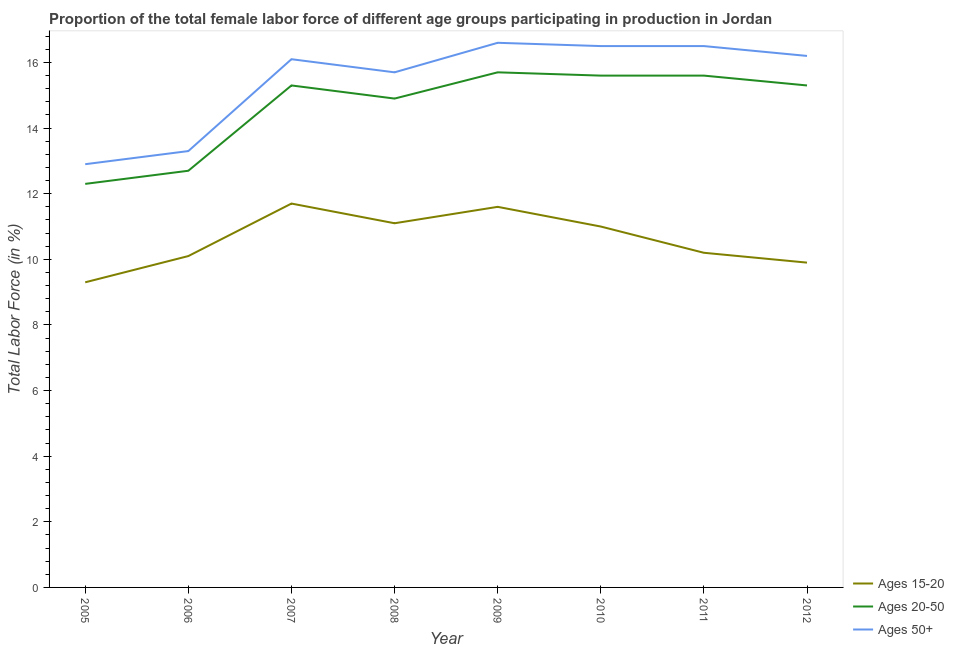What is the percentage of female labor force within the age group 20-50 in 2006?
Provide a succinct answer. 12.7. Across all years, what is the maximum percentage of female labor force above age 50?
Offer a very short reply. 16.6. Across all years, what is the minimum percentage of female labor force above age 50?
Make the answer very short. 12.9. In which year was the percentage of female labor force within the age group 20-50 minimum?
Give a very brief answer. 2005. What is the total percentage of female labor force within the age group 15-20 in the graph?
Provide a short and direct response. 84.9. What is the difference between the percentage of female labor force within the age group 15-20 in 2006 and that in 2009?
Your response must be concise. -1.5. What is the difference between the percentage of female labor force within the age group 15-20 in 2008 and the percentage of female labor force within the age group 20-50 in 2006?
Make the answer very short. -1.6. What is the average percentage of female labor force within the age group 15-20 per year?
Make the answer very short. 10.61. In the year 2012, what is the difference between the percentage of female labor force within the age group 15-20 and percentage of female labor force within the age group 20-50?
Give a very brief answer. -5.4. What is the ratio of the percentage of female labor force within the age group 15-20 in 2005 to that in 2010?
Offer a very short reply. 0.85. Is the percentage of female labor force within the age group 15-20 in 2009 less than that in 2011?
Your answer should be compact. No. What is the difference between the highest and the second highest percentage of female labor force above age 50?
Your answer should be compact. 0.1. What is the difference between the highest and the lowest percentage of female labor force above age 50?
Keep it short and to the point. 3.7. In how many years, is the percentage of female labor force above age 50 greater than the average percentage of female labor force above age 50 taken over all years?
Give a very brief answer. 6. Is the sum of the percentage of female labor force within the age group 20-50 in 2005 and 2008 greater than the maximum percentage of female labor force within the age group 15-20 across all years?
Your answer should be compact. Yes. Is it the case that in every year, the sum of the percentage of female labor force within the age group 15-20 and percentage of female labor force within the age group 20-50 is greater than the percentage of female labor force above age 50?
Give a very brief answer. Yes. Does the percentage of female labor force above age 50 monotonically increase over the years?
Provide a short and direct response. No. Is the percentage of female labor force within the age group 20-50 strictly less than the percentage of female labor force within the age group 15-20 over the years?
Offer a very short reply. No. How many years are there in the graph?
Keep it short and to the point. 8. Does the graph contain any zero values?
Make the answer very short. No. How many legend labels are there?
Provide a succinct answer. 3. What is the title of the graph?
Keep it short and to the point. Proportion of the total female labor force of different age groups participating in production in Jordan. Does "Transport" appear as one of the legend labels in the graph?
Offer a terse response. No. What is the label or title of the X-axis?
Your response must be concise. Year. What is the Total Labor Force (in %) of Ages 15-20 in 2005?
Provide a short and direct response. 9.3. What is the Total Labor Force (in %) in Ages 20-50 in 2005?
Your answer should be very brief. 12.3. What is the Total Labor Force (in %) in Ages 50+ in 2005?
Offer a very short reply. 12.9. What is the Total Labor Force (in %) of Ages 15-20 in 2006?
Give a very brief answer. 10.1. What is the Total Labor Force (in %) of Ages 20-50 in 2006?
Your answer should be very brief. 12.7. What is the Total Labor Force (in %) of Ages 50+ in 2006?
Provide a succinct answer. 13.3. What is the Total Labor Force (in %) in Ages 15-20 in 2007?
Make the answer very short. 11.7. What is the Total Labor Force (in %) of Ages 20-50 in 2007?
Keep it short and to the point. 15.3. What is the Total Labor Force (in %) in Ages 50+ in 2007?
Ensure brevity in your answer.  16.1. What is the Total Labor Force (in %) in Ages 15-20 in 2008?
Provide a succinct answer. 11.1. What is the Total Labor Force (in %) in Ages 20-50 in 2008?
Ensure brevity in your answer.  14.9. What is the Total Labor Force (in %) of Ages 50+ in 2008?
Keep it short and to the point. 15.7. What is the Total Labor Force (in %) of Ages 15-20 in 2009?
Ensure brevity in your answer.  11.6. What is the Total Labor Force (in %) in Ages 20-50 in 2009?
Make the answer very short. 15.7. What is the Total Labor Force (in %) in Ages 50+ in 2009?
Ensure brevity in your answer.  16.6. What is the Total Labor Force (in %) of Ages 15-20 in 2010?
Your response must be concise. 11. What is the Total Labor Force (in %) in Ages 20-50 in 2010?
Your response must be concise. 15.6. What is the Total Labor Force (in %) in Ages 50+ in 2010?
Give a very brief answer. 16.5. What is the Total Labor Force (in %) of Ages 15-20 in 2011?
Offer a very short reply. 10.2. What is the Total Labor Force (in %) in Ages 20-50 in 2011?
Give a very brief answer. 15.6. What is the Total Labor Force (in %) of Ages 50+ in 2011?
Keep it short and to the point. 16.5. What is the Total Labor Force (in %) in Ages 15-20 in 2012?
Your answer should be very brief. 9.9. What is the Total Labor Force (in %) of Ages 20-50 in 2012?
Provide a succinct answer. 15.3. What is the Total Labor Force (in %) in Ages 50+ in 2012?
Make the answer very short. 16.2. Across all years, what is the maximum Total Labor Force (in %) of Ages 15-20?
Your answer should be very brief. 11.7. Across all years, what is the maximum Total Labor Force (in %) of Ages 20-50?
Make the answer very short. 15.7. Across all years, what is the maximum Total Labor Force (in %) in Ages 50+?
Keep it short and to the point. 16.6. Across all years, what is the minimum Total Labor Force (in %) of Ages 15-20?
Provide a succinct answer. 9.3. Across all years, what is the minimum Total Labor Force (in %) of Ages 20-50?
Give a very brief answer. 12.3. Across all years, what is the minimum Total Labor Force (in %) in Ages 50+?
Make the answer very short. 12.9. What is the total Total Labor Force (in %) in Ages 15-20 in the graph?
Give a very brief answer. 84.9. What is the total Total Labor Force (in %) in Ages 20-50 in the graph?
Ensure brevity in your answer.  117.4. What is the total Total Labor Force (in %) of Ages 50+ in the graph?
Ensure brevity in your answer.  123.8. What is the difference between the Total Labor Force (in %) in Ages 20-50 in 2005 and that in 2006?
Your response must be concise. -0.4. What is the difference between the Total Labor Force (in %) of Ages 50+ in 2005 and that in 2006?
Your answer should be compact. -0.4. What is the difference between the Total Labor Force (in %) in Ages 20-50 in 2005 and that in 2007?
Your response must be concise. -3. What is the difference between the Total Labor Force (in %) of Ages 15-20 in 2005 and that in 2008?
Give a very brief answer. -1.8. What is the difference between the Total Labor Force (in %) of Ages 20-50 in 2005 and that in 2008?
Ensure brevity in your answer.  -2.6. What is the difference between the Total Labor Force (in %) in Ages 50+ in 2005 and that in 2009?
Give a very brief answer. -3.7. What is the difference between the Total Labor Force (in %) in Ages 15-20 in 2005 and that in 2010?
Make the answer very short. -1.7. What is the difference between the Total Labor Force (in %) in Ages 15-20 in 2005 and that in 2011?
Give a very brief answer. -0.9. What is the difference between the Total Labor Force (in %) of Ages 20-50 in 2005 and that in 2011?
Make the answer very short. -3.3. What is the difference between the Total Labor Force (in %) in Ages 50+ in 2005 and that in 2011?
Your answer should be compact. -3.6. What is the difference between the Total Labor Force (in %) in Ages 50+ in 2005 and that in 2012?
Your answer should be very brief. -3.3. What is the difference between the Total Labor Force (in %) of Ages 20-50 in 2006 and that in 2007?
Provide a short and direct response. -2.6. What is the difference between the Total Labor Force (in %) of Ages 15-20 in 2006 and that in 2008?
Provide a short and direct response. -1. What is the difference between the Total Labor Force (in %) in Ages 15-20 in 2006 and that in 2009?
Ensure brevity in your answer.  -1.5. What is the difference between the Total Labor Force (in %) in Ages 50+ in 2006 and that in 2009?
Make the answer very short. -3.3. What is the difference between the Total Labor Force (in %) in Ages 15-20 in 2006 and that in 2010?
Offer a very short reply. -0.9. What is the difference between the Total Labor Force (in %) of Ages 15-20 in 2006 and that in 2011?
Ensure brevity in your answer.  -0.1. What is the difference between the Total Labor Force (in %) of Ages 20-50 in 2006 and that in 2011?
Give a very brief answer. -2.9. What is the difference between the Total Labor Force (in %) of Ages 20-50 in 2006 and that in 2012?
Offer a very short reply. -2.6. What is the difference between the Total Labor Force (in %) of Ages 20-50 in 2007 and that in 2008?
Offer a very short reply. 0.4. What is the difference between the Total Labor Force (in %) of Ages 50+ in 2007 and that in 2008?
Make the answer very short. 0.4. What is the difference between the Total Labor Force (in %) of Ages 20-50 in 2007 and that in 2009?
Offer a terse response. -0.4. What is the difference between the Total Labor Force (in %) in Ages 50+ in 2007 and that in 2009?
Provide a short and direct response. -0.5. What is the difference between the Total Labor Force (in %) of Ages 50+ in 2007 and that in 2011?
Give a very brief answer. -0.4. What is the difference between the Total Labor Force (in %) in Ages 15-20 in 2007 and that in 2012?
Make the answer very short. 1.8. What is the difference between the Total Labor Force (in %) of Ages 50+ in 2007 and that in 2012?
Make the answer very short. -0.1. What is the difference between the Total Labor Force (in %) in Ages 50+ in 2008 and that in 2009?
Keep it short and to the point. -0.9. What is the difference between the Total Labor Force (in %) in Ages 15-20 in 2008 and that in 2010?
Keep it short and to the point. 0.1. What is the difference between the Total Labor Force (in %) in Ages 20-50 in 2008 and that in 2010?
Provide a succinct answer. -0.7. What is the difference between the Total Labor Force (in %) of Ages 20-50 in 2008 and that in 2011?
Your answer should be compact. -0.7. What is the difference between the Total Labor Force (in %) in Ages 50+ in 2008 and that in 2011?
Give a very brief answer. -0.8. What is the difference between the Total Labor Force (in %) of Ages 20-50 in 2008 and that in 2012?
Ensure brevity in your answer.  -0.4. What is the difference between the Total Labor Force (in %) of Ages 50+ in 2008 and that in 2012?
Give a very brief answer. -0.5. What is the difference between the Total Labor Force (in %) in Ages 15-20 in 2009 and that in 2010?
Your response must be concise. 0.6. What is the difference between the Total Labor Force (in %) of Ages 50+ in 2009 and that in 2010?
Make the answer very short. 0.1. What is the difference between the Total Labor Force (in %) of Ages 50+ in 2009 and that in 2011?
Provide a succinct answer. 0.1. What is the difference between the Total Labor Force (in %) in Ages 15-20 in 2009 and that in 2012?
Keep it short and to the point. 1.7. What is the difference between the Total Labor Force (in %) in Ages 20-50 in 2009 and that in 2012?
Provide a succinct answer. 0.4. What is the difference between the Total Labor Force (in %) of Ages 15-20 in 2010 and that in 2011?
Your response must be concise. 0.8. What is the difference between the Total Labor Force (in %) in Ages 20-50 in 2010 and that in 2011?
Offer a terse response. 0. What is the difference between the Total Labor Force (in %) in Ages 15-20 in 2011 and that in 2012?
Your answer should be very brief. 0.3. What is the difference between the Total Labor Force (in %) of Ages 20-50 in 2011 and that in 2012?
Offer a terse response. 0.3. What is the difference between the Total Labor Force (in %) of Ages 50+ in 2011 and that in 2012?
Your answer should be very brief. 0.3. What is the difference between the Total Labor Force (in %) in Ages 15-20 in 2005 and the Total Labor Force (in %) in Ages 20-50 in 2006?
Ensure brevity in your answer.  -3.4. What is the difference between the Total Labor Force (in %) of Ages 15-20 in 2005 and the Total Labor Force (in %) of Ages 20-50 in 2007?
Offer a terse response. -6. What is the difference between the Total Labor Force (in %) of Ages 15-20 in 2005 and the Total Labor Force (in %) of Ages 50+ in 2007?
Provide a succinct answer. -6.8. What is the difference between the Total Labor Force (in %) of Ages 20-50 in 2005 and the Total Labor Force (in %) of Ages 50+ in 2007?
Make the answer very short. -3.8. What is the difference between the Total Labor Force (in %) in Ages 15-20 in 2005 and the Total Labor Force (in %) in Ages 50+ in 2008?
Make the answer very short. -6.4. What is the difference between the Total Labor Force (in %) in Ages 15-20 in 2005 and the Total Labor Force (in %) in Ages 20-50 in 2009?
Make the answer very short. -6.4. What is the difference between the Total Labor Force (in %) in Ages 15-20 in 2005 and the Total Labor Force (in %) in Ages 50+ in 2009?
Provide a short and direct response. -7.3. What is the difference between the Total Labor Force (in %) of Ages 20-50 in 2005 and the Total Labor Force (in %) of Ages 50+ in 2009?
Give a very brief answer. -4.3. What is the difference between the Total Labor Force (in %) of Ages 15-20 in 2005 and the Total Labor Force (in %) of Ages 50+ in 2011?
Your answer should be compact. -7.2. What is the difference between the Total Labor Force (in %) of Ages 20-50 in 2005 and the Total Labor Force (in %) of Ages 50+ in 2011?
Provide a succinct answer. -4.2. What is the difference between the Total Labor Force (in %) of Ages 15-20 in 2006 and the Total Labor Force (in %) of Ages 50+ in 2007?
Keep it short and to the point. -6. What is the difference between the Total Labor Force (in %) of Ages 15-20 in 2006 and the Total Labor Force (in %) of Ages 50+ in 2008?
Give a very brief answer. -5.6. What is the difference between the Total Labor Force (in %) of Ages 20-50 in 2006 and the Total Labor Force (in %) of Ages 50+ in 2008?
Keep it short and to the point. -3. What is the difference between the Total Labor Force (in %) in Ages 15-20 in 2006 and the Total Labor Force (in %) in Ages 20-50 in 2009?
Ensure brevity in your answer.  -5.6. What is the difference between the Total Labor Force (in %) of Ages 20-50 in 2006 and the Total Labor Force (in %) of Ages 50+ in 2009?
Give a very brief answer. -3.9. What is the difference between the Total Labor Force (in %) in Ages 15-20 in 2006 and the Total Labor Force (in %) in Ages 20-50 in 2010?
Your answer should be very brief. -5.5. What is the difference between the Total Labor Force (in %) of Ages 15-20 in 2006 and the Total Labor Force (in %) of Ages 50+ in 2010?
Offer a terse response. -6.4. What is the difference between the Total Labor Force (in %) of Ages 15-20 in 2006 and the Total Labor Force (in %) of Ages 20-50 in 2011?
Give a very brief answer. -5.5. What is the difference between the Total Labor Force (in %) of Ages 15-20 in 2006 and the Total Labor Force (in %) of Ages 50+ in 2011?
Make the answer very short. -6.4. What is the difference between the Total Labor Force (in %) of Ages 15-20 in 2006 and the Total Labor Force (in %) of Ages 20-50 in 2012?
Your answer should be compact. -5.2. What is the difference between the Total Labor Force (in %) in Ages 15-20 in 2006 and the Total Labor Force (in %) in Ages 50+ in 2012?
Ensure brevity in your answer.  -6.1. What is the difference between the Total Labor Force (in %) in Ages 15-20 in 2007 and the Total Labor Force (in %) in Ages 20-50 in 2009?
Your answer should be compact. -4. What is the difference between the Total Labor Force (in %) in Ages 20-50 in 2007 and the Total Labor Force (in %) in Ages 50+ in 2010?
Provide a succinct answer. -1.2. What is the difference between the Total Labor Force (in %) of Ages 15-20 in 2007 and the Total Labor Force (in %) of Ages 50+ in 2011?
Offer a terse response. -4.8. What is the difference between the Total Labor Force (in %) in Ages 15-20 in 2007 and the Total Labor Force (in %) in Ages 20-50 in 2012?
Give a very brief answer. -3.6. What is the difference between the Total Labor Force (in %) of Ages 15-20 in 2008 and the Total Labor Force (in %) of Ages 20-50 in 2009?
Offer a very short reply. -4.6. What is the difference between the Total Labor Force (in %) of Ages 20-50 in 2008 and the Total Labor Force (in %) of Ages 50+ in 2009?
Give a very brief answer. -1.7. What is the difference between the Total Labor Force (in %) in Ages 15-20 in 2008 and the Total Labor Force (in %) in Ages 20-50 in 2010?
Your answer should be compact. -4.5. What is the difference between the Total Labor Force (in %) in Ages 15-20 in 2008 and the Total Labor Force (in %) in Ages 50+ in 2011?
Keep it short and to the point. -5.4. What is the difference between the Total Labor Force (in %) of Ages 15-20 in 2008 and the Total Labor Force (in %) of Ages 20-50 in 2012?
Your response must be concise. -4.2. What is the difference between the Total Labor Force (in %) in Ages 20-50 in 2008 and the Total Labor Force (in %) in Ages 50+ in 2012?
Make the answer very short. -1.3. What is the difference between the Total Labor Force (in %) in Ages 15-20 in 2009 and the Total Labor Force (in %) in Ages 20-50 in 2012?
Offer a very short reply. -3.7. What is the difference between the Total Labor Force (in %) of Ages 15-20 in 2009 and the Total Labor Force (in %) of Ages 50+ in 2012?
Offer a terse response. -4.6. What is the difference between the Total Labor Force (in %) of Ages 20-50 in 2009 and the Total Labor Force (in %) of Ages 50+ in 2012?
Offer a terse response. -0.5. What is the difference between the Total Labor Force (in %) of Ages 15-20 in 2010 and the Total Labor Force (in %) of Ages 20-50 in 2011?
Your answer should be very brief. -4.6. What is the difference between the Total Labor Force (in %) in Ages 20-50 in 2010 and the Total Labor Force (in %) in Ages 50+ in 2011?
Provide a succinct answer. -0.9. What is the difference between the Total Labor Force (in %) in Ages 15-20 in 2010 and the Total Labor Force (in %) in Ages 20-50 in 2012?
Make the answer very short. -4.3. What is the difference between the Total Labor Force (in %) of Ages 15-20 in 2010 and the Total Labor Force (in %) of Ages 50+ in 2012?
Give a very brief answer. -5.2. What is the average Total Labor Force (in %) in Ages 15-20 per year?
Make the answer very short. 10.61. What is the average Total Labor Force (in %) of Ages 20-50 per year?
Your answer should be very brief. 14.68. What is the average Total Labor Force (in %) in Ages 50+ per year?
Offer a terse response. 15.47. In the year 2005, what is the difference between the Total Labor Force (in %) in Ages 15-20 and Total Labor Force (in %) in Ages 20-50?
Offer a very short reply. -3. In the year 2006, what is the difference between the Total Labor Force (in %) in Ages 15-20 and Total Labor Force (in %) in Ages 50+?
Your answer should be very brief. -3.2. In the year 2006, what is the difference between the Total Labor Force (in %) of Ages 20-50 and Total Labor Force (in %) of Ages 50+?
Your answer should be compact. -0.6. In the year 2008, what is the difference between the Total Labor Force (in %) of Ages 15-20 and Total Labor Force (in %) of Ages 20-50?
Provide a succinct answer. -3.8. In the year 2008, what is the difference between the Total Labor Force (in %) of Ages 20-50 and Total Labor Force (in %) of Ages 50+?
Offer a terse response. -0.8. In the year 2009, what is the difference between the Total Labor Force (in %) of Ages 20-50 and Total Labor Force (in %) of Ages 50+?
Your response must be concise. -0.9. In the year 2010, what is the difference between the Total Labor Force (in %) in Ages 15-20 and Total Labor Force (in %) in Ages 20-50?
Provide a short and direct response. -4.6. In the year 2010, what is the difference between the Total Labor Force (in %) of Ages 15-20 and Total Labor Force (in %) of Ages 50+?
Provide a succinct answer. -5.5. In the year 2010, what is the difference between the Total Labor Force (in %) in Ages 20-50 and Total Labor Force (in %) in Ages 50+?
Give a very brief answer. -0.9. In the year 2012, what is the difference between the Total Labor Force (in %) of Ages 15-20 and Total Labor Force (in %) of Ages 20-50?
Give a very brief answer. -5.4. In the year 2012, what is the difference between the Total Labor Force (in %) in Ages 15-20 and Total Labor Force (in %) in Ages 50+?
Your answer should be compact. -6.3. In the year 2012, what is the difference between the Total Labor Force (in %) in Ages 20-50 and Total Labor Force (in %) in Ages 50+?
Your answer should be very brief. -0.9. What is the ratio of the Total Labor Force (in %) of Ages 15-20 in 2005 to that in 2006?
Give a very brief answer. 0.92. What is the ratio of the Total Labor Force (in %) of Ages 20-50 in 2005 to that in 2006?
Your answer should be very brief. 0.97. What is the ratio of the Total Labor Force (in %) in Ages 50+ in 2005 to that in 2006?
Your answer should be compact. 0.97. What is the ratio of the Total Labor Force (in %) in Ages 15-20 in 2005 to that in 2007?
Give a very brief answer. 0.79. What is the ratio of the Total Labor Force (in %) of Ages 20-50 in 2005 to that in 2007?
Make the answer very short. 0.8. What is the ratio of the Total Labor Force (in %) of Ages 50+ in 2005 to that in 2007?
Keep it short and to the point. 0.8. What is the ratio of the Total Labor Force (in %) in Ages 15-20 in 2005 to that in 2008?
Ensure brevity in your answer.  0.84. What is the ratio of the Total Labor Force (in %) in Ages 20-50 in 2005 to that in 2008?
Your response must be concise. 0.83. What is the ratio of the Total Labor Force (in %) in Ages 50+ in 2005 to that in 2008?
Make the answer very short. 0.82. What is the ratio of the Total Labor Force (in %) of Ages 15-20 in 2005 to that in 2009?
Make the answer very short. 0.8. What is the ratio of the Total Labor Force (in %) of Ages 20-50 in 2005 to that in 2009?
Your answer should be very brief. 0.78. What is the ratio of the Total Labor Force (in %) of Ages 50+ in 2005 to that in 2009?
Your answer should be very brief. 0.78. What is the ratio of the Total Labor Force (in %) in Ages 15-20 in 2005 to that in 2010?
Provide a short and direct response. 0.85. What is the ratio of the Total Labor Force (in %) of Ages 20-50 in 2005 to that in 2010?
Provide a short and direct response. 0.79. What is the ratio of the Total Labor Force (in %) in Ages 50+ in 2005 to that in 2010?
Keep it short and to the point. 0.78. What is the ratio of the Total Labor Force (in %) in Ages 15-20 in 2005 to that in 2011?
Offer a very short reply. 0.91. What is the ratio of the Total Labor Force (in %) in Ages 20-50 in 2005 to that in 2011?
Offer a terse response. 0.79. What is the ratio of the Total Labor Force (in %) in Ages 50+ in 2005 to that in 2011?
Offer a terse response. 0.78. What is the ratio of the Total Labor Force (in %) in Ages 15-20 in 2005 to that in 2012?
Ensure brevity in your answer.  0.94. What is the ratio of the Total Labor Force (in %) in Ages 20-50 in 2005 to that in 2012?
Offer a very short reply. 0.8. What is the ratio of the Total Labor Force (in %) of Ages 50+ in 2005 to that in 2012?
Your answer should be very brief. 0.8. What is the ratio of the Total Labor Force (in %) in Ages 15-20 in 2006 to that in 2007?
Your response must be concise. 0.86. What is the ratio of the Total Labor Force (in %) of Ages 20-50 in 2006 to that in 2007?
Ensure brevity in your answer.  0.83. What is the ratio of the Total Labor Force (in %) of Ages 50+ in 2006 to that in 2007?
Keep it short and to the point. 0.83. What is the ratio of the Total Labor Force (in %) of Ages 15-20 in 2006 to that in 2008?
Offer a very short reply. 0.91. What is the ratio of the Total Labor Force (in %) of Ages 20-50 in 2006 to that in 2008?
Provide a succinct answer. 0.85. What is the ratio of the Total Labor Force (in %) of Ages 50+ in 2006 to that in 2008?
Provide a succinct answer. 0.85. What is the ratio of the Total Labor Force (in %) of Ages 15-20 in 2006 to that in 2009?
Your answer should be compact. 0.87. What is the ratio of the Total Labor Force (in %) in Ages 20-50 in 2006 to that in 2009?
Offer a terse response. 0.81. What is the ratio of the Total Labor Force (in %) of Ages 50+ in 2006 to that in 2009?
Your response must be concise. 0.8. What is the ratio of the Total Labor Force (in %) in Ages 15-20 in 2006 to that in 2010?
Provide a succinct answer. 0.92. What is the ratio of the Total Labor Force (in %) in Ages 20-50 in 2006 to that in 2010?
Offer a very short reply. 0.81. What is the ratio of the Total Labor Force (in %) in Ages 50+ in 2006 to that in 2010?
Ensure brevity in your answer.  0.81. What is the ratio of the Total Labor Force (in %) in Ages 15-20 in 2006 to that in 2011?
Provide a succinct answer. 0.99. What is the ratio of the Total Labor Force (in %) of Ages 20-50 in 2006 to that in 2011?
Your answer should be very brief. 0.81. What is the ratio of the Total Labor Force (in %) of Ages 50+ in 2006 to that in 2011?
Your answer should be compact. 0.81. What is the ratio of the Total Labor Force (in %) of Ages 15-20 in 2006 to that in 2012?
Provide a short and direct response. 1.02. What is the ratio of the Total Labor Force (in %) of Ages 20-50 in 2006 to that in 2012?
Offer a very short reply. 0.83. What is the ratio of the Total Labor Force (in %) in Ages 50+ in 2006 to that in 2012?
Provide a succinct answer. 0.82. What is the ratio of the Total Labor Force (in %) in Ages 15-20 in 2007 to that in 2008?
Ensure brevity in your answer.  1.05. What is the ratio of the Total Labor Force (in %) in Ages 20-50 in 2007 to that in 2008?
Offer a terse response. 1.03. What is the ratio of the Total Labor Force (in %) in Ages 50+ in 2007 to that in 2008?
Your answer should be very brief. 1.03. What is the ratio of the Total Labor Force (in %) of Ages 15-20 in 2007 to that in 2009?
Offer a terse response. 1.01. What is the ratio of the Total Labor Force (in %) in Ages 20-50 in 2007 to that in 2009?
Offer a terse response. 0.97. What is the ratio of the Total Labor Force (in %) in Ages 50+ in 2007 to that in 2009?
Keep it short and to the point. 0.97. What is the ratio of the Total Labor Force (in %) of Ages 15-20 in 2007 to that in 2010?
Your answer should be compact. 1.06. What is the ratio of the Total Labor Force (in %) in Ages 20-50 in 2007 to that in 2010?
Provide a short and direct response. 0.98. What is the ratio of the Total Labor Force (in %) in Ages 50+ in 2007 to that in 2010?
Your answer should be compact. 0.98. What is the ratio of the Total Labor Force (in %) of Ages 15-20 in 2007 to that in 2011?
Your answer should be very brief. 1.15. What is the ratio of the Total Labor Force (in %) of Ages 20-50 in 2007 to that in 2011?
Keep it short and to the point. 0.98. What is the ratio of the Total Labor Force (in %) in Ages 50+ in 2007 to that in 2011?
Your answer should be compact. 0.98. What is the ratio of the Total Labor Force (in %) of Ages 15-20 in 2007 to that in 2012?
Make the answer very short. 1.18. What is the ratio of the Total Labor Force (in %) in Ages 15-20 in 2008 to that in 2009?
Make the answer very short. 0.96. What is the ratio of the Total Labor Force (in %) in Ages 20-50 in 2008 to that in 2009?
Offer a terse response. 0.95. What is the ratio of the Total Labor Force (in %) in Ages 50+ in 2008 to that in 2009?
Make the answer very short. 0.95. What is the ratio of the Total Labor Force (in %) of Ages 15-20 in 2008 to that in 2010?
Give a very brief answer. 1.01. What is the ratio of the Total Labor Force (in %) in Ages 20-50 in 2008 to that in 2010?
Offer a very short reply. 0.96. What is the ratio of the Total Labor Force (in %) in Ages 50+ in 2008 to that in 2010?
Make the answer very short. 0.95. What is the ratio of the Total Labor Force (in %) in Ages 15-20 in 2008 to that in 2011?
Keep it short and to the point. 1.09. What is the ratio of the Total Labor Force (in %) of Ages 20-50 in 2008 to that in 2011?
Offer a very short reply. 0.96. What is the ratio of the Total Labor Force (in %) of Ages 50+ in 2008 to that in 2011?
Your answer should be compact. 0.95. What is the ratio of the Total Labor Force (in %) in Ages 15-20 in 2008 to that in 2012?
Give a very brief answer. 1.12. What is the ratio of the Total Labor Force (in %) in Ages 20-50 in 2008 to that in 2012?
Your response must be concise. 0.97. What is the ratio of the Total Labor Force (in %) in Ages 50+ in 2008 to that in 2012?
Provide a succinct answer. 0.97. What is the ratio of the Total Labor Force (in %) in Ages 15-20 in 2009 to that in 2010?
Your answer should be compact. 1.05. What is the ratio of the Total Labor Force (in %) of Ages 20-50 in 2009 to that in 2010?
Provide a short and direct response. 1.01. What is the ratio of the Total Labor Force (in %) in Ages 50+ in 2009 to that in 2010?
Offer a very short reply. 1.01. What is the ratio of the Total Labor Force (in %) of Ages 15-20 in 2009 to that in 2011?
Provide a succinct answer. 1.14. What is the ratio of the Total Labor Force (in %) in Ages 20-50 in 2009 to that in 2011?
Give a very brief answer. 1.01. What is the ratio of the Total Labor Force (in %) of Ages 50+ in 2009 to that in 2011?
Your answer should be very brief. 1.01. What is the ratio of the Total Labor Force (in %) in Ages 15-20 in 2009 to that in 2012?
Offer a very short reply. 1.17. What is the ratio of the Total Labor Force (in %) in Ages 20-50 in 2009 to that in 2012?
Provide a short and direct response. 1.03. What is the ratio of the Total Labor Force (in %) of Ages 50+ in 2009 to that in 2012?
Provide a short and direct response. 1.02. What is the ratio of the Total Labor Force (in %) in Ages 15-20 in 2010 to that in 2011?
Your answer should be very brief. 1.08. What is the ratio of the Total Labor Force (in %) in Ages 50+ in 2010 to that in 2011?
Provide a succinct answer. 1. What is the ratio of the Total Labor Force (in %) in Ages 20-50 in 2010 to that in 2012?
Offer a terse response. 1.02. What is the ratio of the Total Labor Force (in %) in Ages 50+ in 2010 to that in 2012?
Your answer should be very brief. 1.02. What is the ratio of the Total Labor Force (in %) of Ages 15-20 in 2011 to that in 2012?
Offer a very short reply. 1.03. What is the ratio of the Total Labor Force (in %) of Ages 20-50 in 2011 to that in 2012?
Provide a short and direct response. 1.02. What is the ratio of the Total Labor Force (in %) of Ages 50+ in 2011 to that in 2012?
Your response must be concise. 1.02. What is the difference between the highest and the second highest Total Labor Force (in %) in Ages 20-50?
Ensure brevity in your answer.  0.1. What is the difference between the highest and the second highest Total Labor Force (in %) in Ages 50+?
Give a very brief answer. 0.1. What is the difference between the highest and the lowest Total Labor Force (in %) of Ages 15-20?
Provide a succinct answer. 2.4. What is the difference between the highest and the lowest Total Labor Force (in %) of Ages 20-50?
Provide a succinct answer. 3.4. What is the difference between the highest and the lowest Total Labor Force (in %) of Ages 50+?
Offer a terse response. 3.7. 